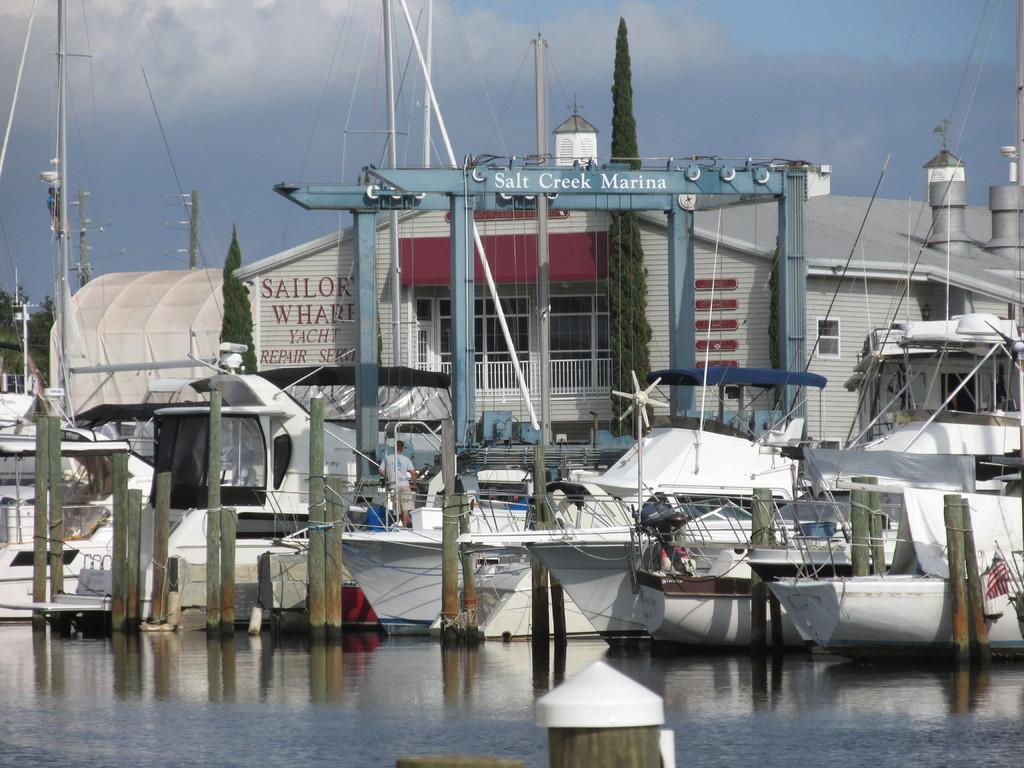<image>
Relay a brief, clear account of the picture shown. White boats docked at a place which says Salt Creek Marina. 